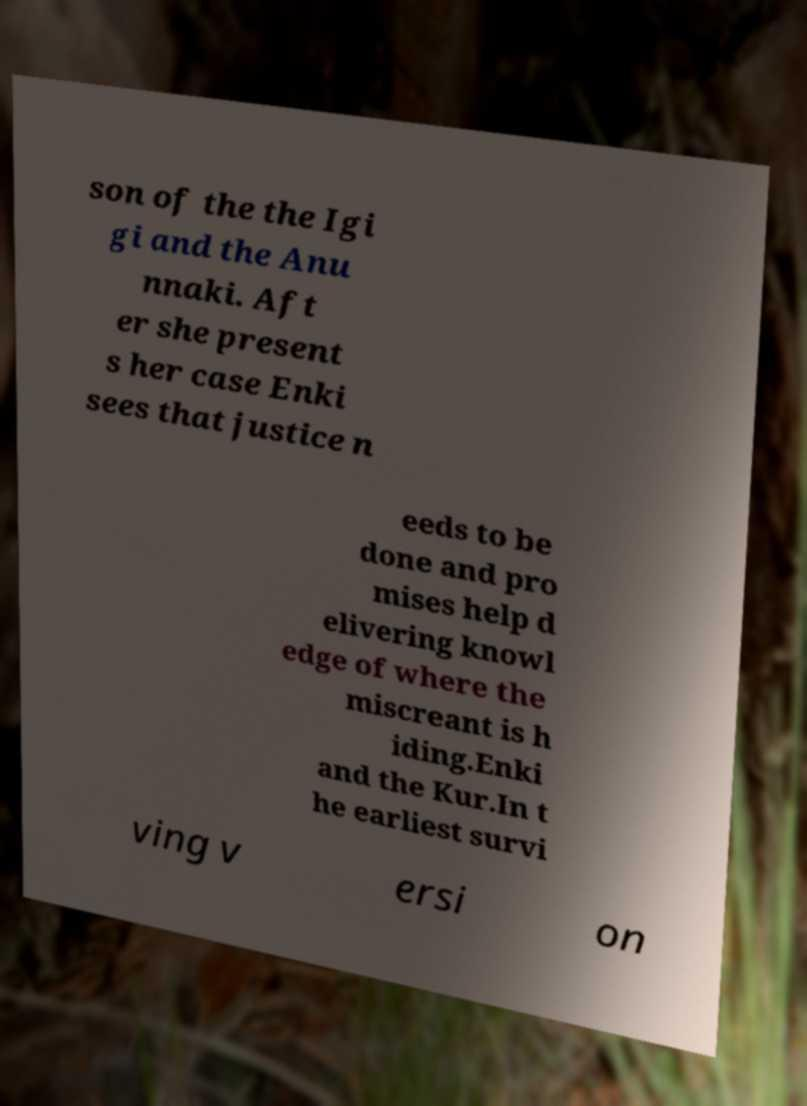For documentation purposes, I need the text within this image transcribed. Could you provide that? son of the the Igi gi and the Anu nnaki. Aft er she present s her case Enki sees that justice n eeds to be done and pro mises help d elivering knowl edge of where the miscreant is h iding.Enki and the Kur.In t he earliest survi ving v ersi on 